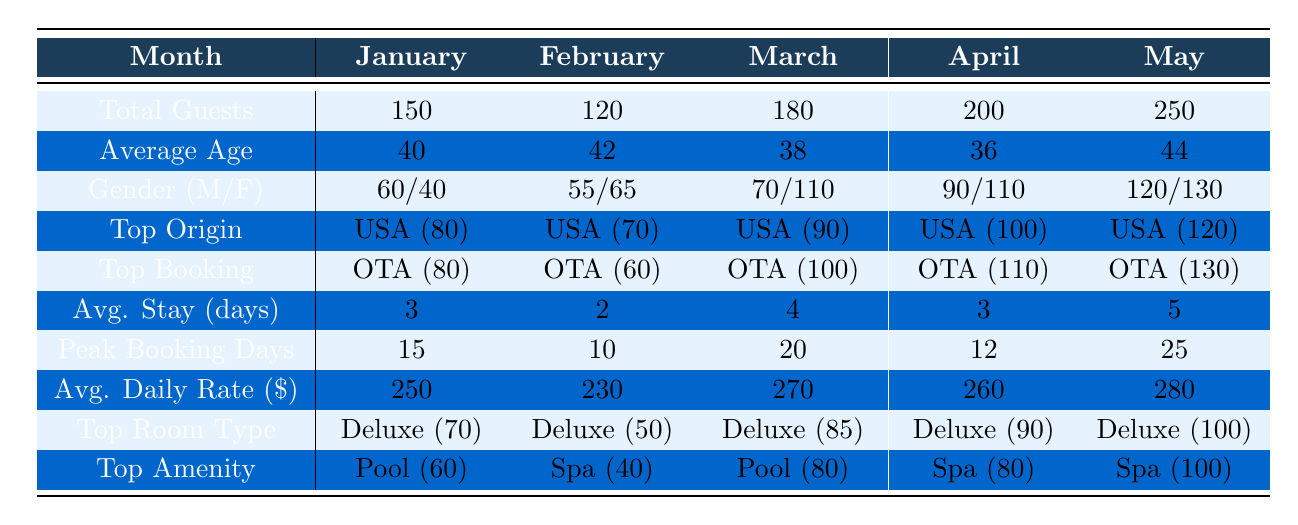What was the total number of guests in May 2023? Referring to the table under the "Total Guests" row for May, it shows there were 250 guests.
Answer: 250 Which month had the highest average age of guests? Looking at the "Average Age" row, February had the highest average age at 42.
Answer: February How many guests originated from the USA in April 2023? In the "Top Origin" row for April, it specifies that the number of guests from the USA was 100.
Answer: 100 Did the average daily rate increase from January to May 2023? Comparing the "Avg. Daily Rate" across the months, the rates are $250 (January) to $280 (May), confirming an increase.
Answer: Yes What is the difference in total guests between March and April 2023? The number of guests in March was 180 and in April was 200. The difference is calculated as 200 - 180 = 20.
Answer: 20 What percentage of guests in January were male? In January, there were 150 total guests with 60 males. The percentage is calculated as (60/150) * 100 = 40%.
Answer: 40% Which booking source had the highest values in all months? Analyzing the "Top Booking" row, the OTA consistently had the highest values each month: 80, 60, 100, 110, and 130.
Answer: OTA What was the average length of stay in the months with the highest number of total guests? May had the highest total guests at 250 with an average stay of 5 days, and April had 200 guests with an average stay of 3 days. The average for these two months is (5 + 3) / 2 = 4 days.
Answer: 4 days How does the average length of stay compare between January and February? For January, the average length of stay is 3 days and for February, it's 2 days. Thus, January has a longer average length of stay by 1 day.
Answer: January is longer by 1 day Was there a month where the number of female guests exceeded male guests? Comparing the gender distribution, in February there were 65 females and 55 males, indicating females exceeded males.
Answer: Yes 